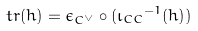Convert formula to latex. <formula><loc_0><loc_0><loc_500><loc_500>t r ( h ) = \epsilon _ { C ^ { \vee } } \circ ( { \iota _ { C C } } ^ { - 1 } ( h ) )</formula> 